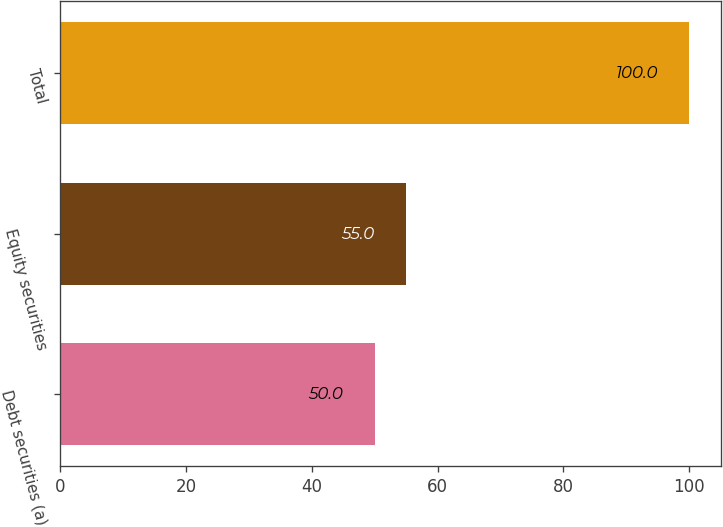Convert chart. <chart><loc_0><loc_0><loc_500><loc_500><bar_chart><fcel>Debt securities (a)<fcel>Equity securities<fcel>Total<nl><fcel>50<fcel>55<fcel>100<nl></chart> 